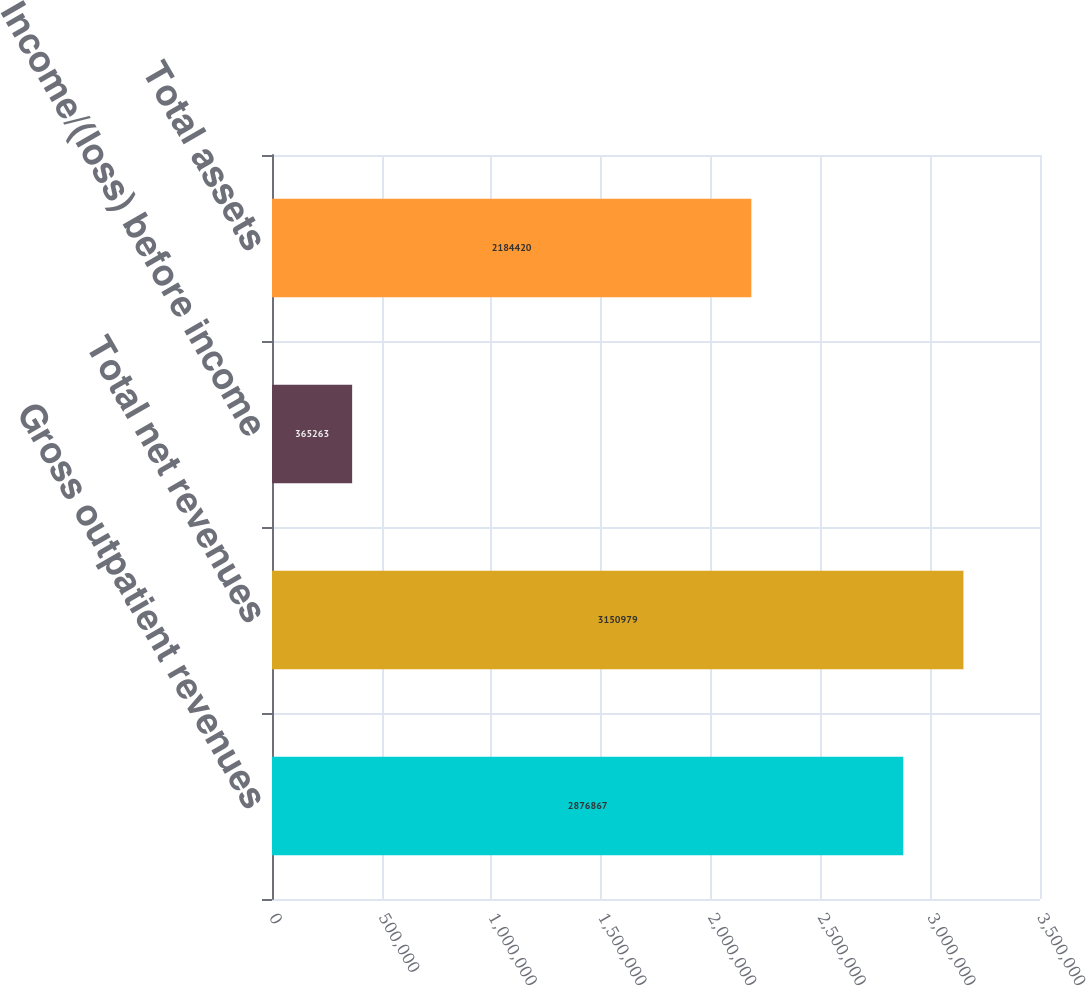Convert chart to OTSL. <chart><loc_0><loc_0><loc_500><loc_500><bar_chart><fcel>Gross outpatient revenues<fcel>Total net revenues<fcel>Income/(loss) before income<fcel>Total assets<nl><fcel>2.87687e+06<fcel>3.15098e+06<fcel>365263<fcel>2.18442e+06<nl></chart> 